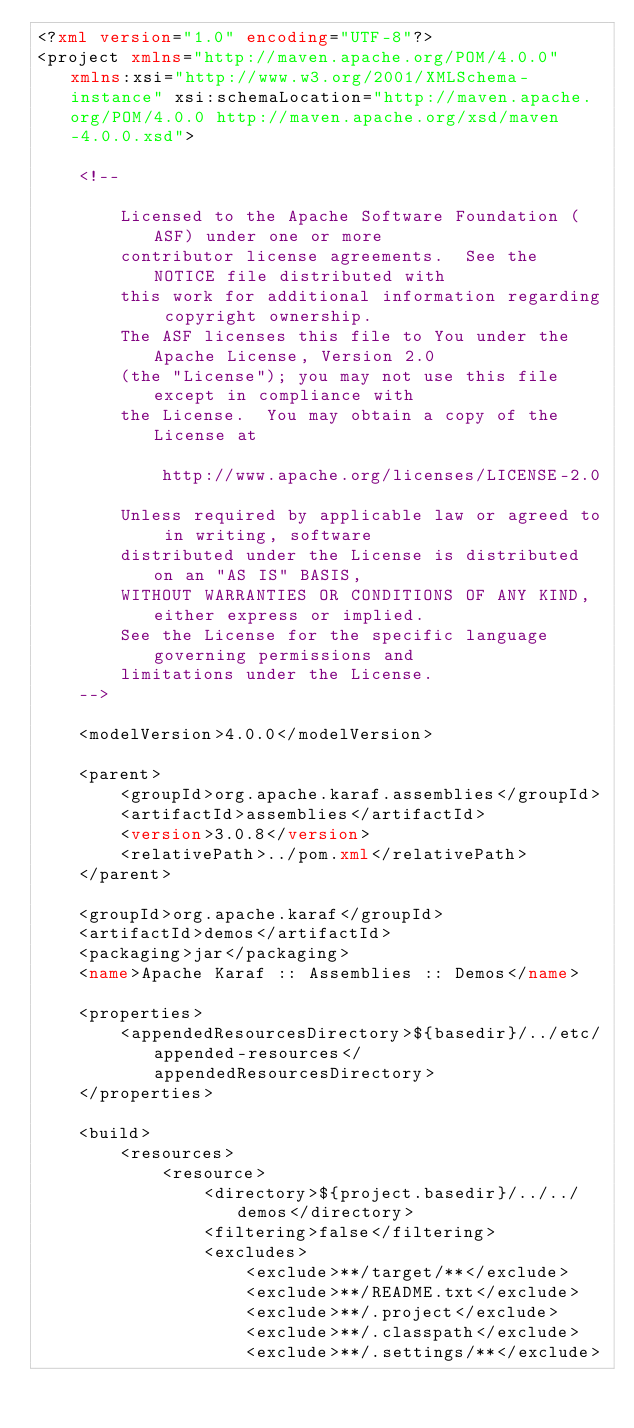<code> <loc_0><loc_0><loc_500><loc_500><_XML_><?xml version="1.0" encoding="UTF-8"?>
<project xmlns="http://maven.apache.org/POM/4.0.0" xmlns:xsi="http://www.w3.org/2001/XMLSchema-instance" xsi:schemaLocation="http://maven.apache.org/POM/4.0.0 http://maven.apache.org/xsd/maven-4.0.0.xsd">

    <!--

        Licensed to the Apache Software Foundation (ASF) under one or more
        contributor license agreements.  See the NOTICE file distributed with
        this work for additional information regarding copyright ownership.
        The ASF licenses this file to You under the Apache License, Version 2.0
        (the "License"); you may not use this file except in compliance with
        the License.  You may obtain a copy of the License at

            http://www.apache.org/licenses/LICENSE-2.0

        Unless required by applicable law or agreed to in writing, software
        distributed under the License is distributed on an "AS IS" BASIS,
        WITHOUT WARRANTIES OR CONDITIONS OF ANY KIND, either express or implied.
        See the License for the specific language governing permissions and
        limitations under the License.
    -->

    <modelVersion>4.0.0</modelVersion>

    <parent>
        <groupId>org.apache.karaf.assemblies</groupId>
        <artifactId>assemblies</artifactId>
        <version>3.0.8</version>
        <relativePath>../pom.xml</relativePath>
    </parent>

    <groupId>org.apache.karaf</groupId>
    <artifactId>demos</artifactId>
    <packaging>jar</packaging>
    <name>Apache Karaf :: Assemblies :: Demos</name>

    <properties>
        <appendedResourcesDirectory>${basedir}/../etc/appended-resources</appendedResourcesDirectory>
    </properties>

    <build>
        <resources>
            <resource>
                <directory>${project.basedir}/../../demos</directory>
                <filtering>false</filtering>
                <excludes>
                    <exclude>**/target/**</exclude>
                    <exclude>**/README.txt</exclude>
                    <exclude>**/.project</exclude>
                    <exclude>**/.classpath</exclude>
                    <exclude>**/.settings/**</exclude></code> 